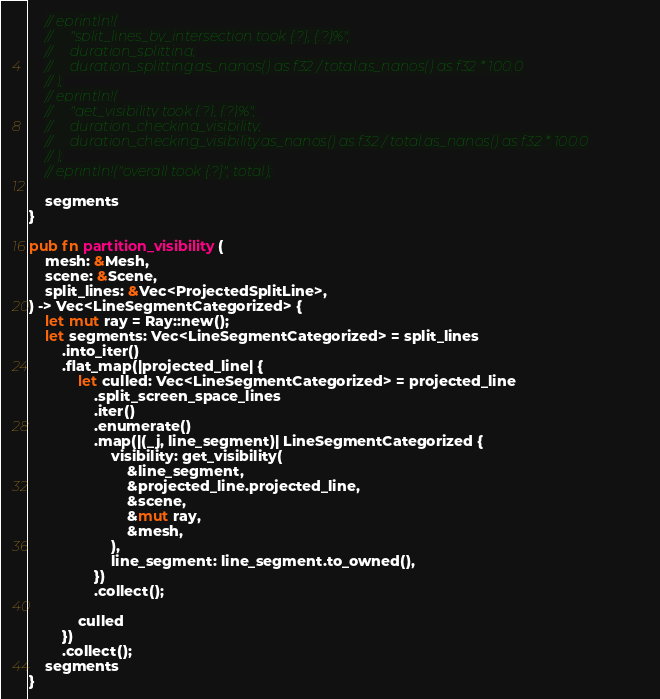<code> <loc_0><loc_0><loc_500><loc_500><_Rust_>    // eprintln!(
    //     "split_lines_by_intersection took {:?}, {:?}%",
    //     duration_splitting,
    //     duration_splitting.as_nanos() as f32 / total.as_nanos() as f32 * 100.0
    // );
    // eprintln!(
    //     "get_visibility took {:?}, {:?}%",
    //     duration_checking_visibility,
    //     duration_checking_visibility.as_nanos() as f32 / total.as_nanos() as f32 * 100.0
    // );
    // eprintln!("overall took {:?}", total);

    segments
}

pub fn partition_visibility(
    mesh: &Mesh,
    scene: &Scene,
    split_lines: &Vec<ProjectedSplitLine>,
) -> Vec<LineSegmentCategorized> {
    let mut ray = Ray::new();
    let segments: Vec<LineSegmentCategorized> = split_lines
        .into_iter()
        .flat_map(|projected_line| {
            let culled: Vec<LineSegmentCategorized> = projected_line
                .split_screen_space_lines
                .iter()
                .enumerate()
                .map(|(_j, line_segment)| LineSegmentCategorized {
                    visibility: get_visibility(
                        &line_segment,
                        &projected_line.projected_line,
                        &scene,
                        &mut ray,
                        &mesh,
                    ),
                    line_segment: line_segment.to_owned(),
                })
                .collect();

            culled
        })
        .collect();
    segments
}
</code> 